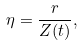Convert formula to latex. <formula><loc_0><loc_0><loc_500><loc_500>\eta = \frac { r } { Z ( t ) } ,</formula> 